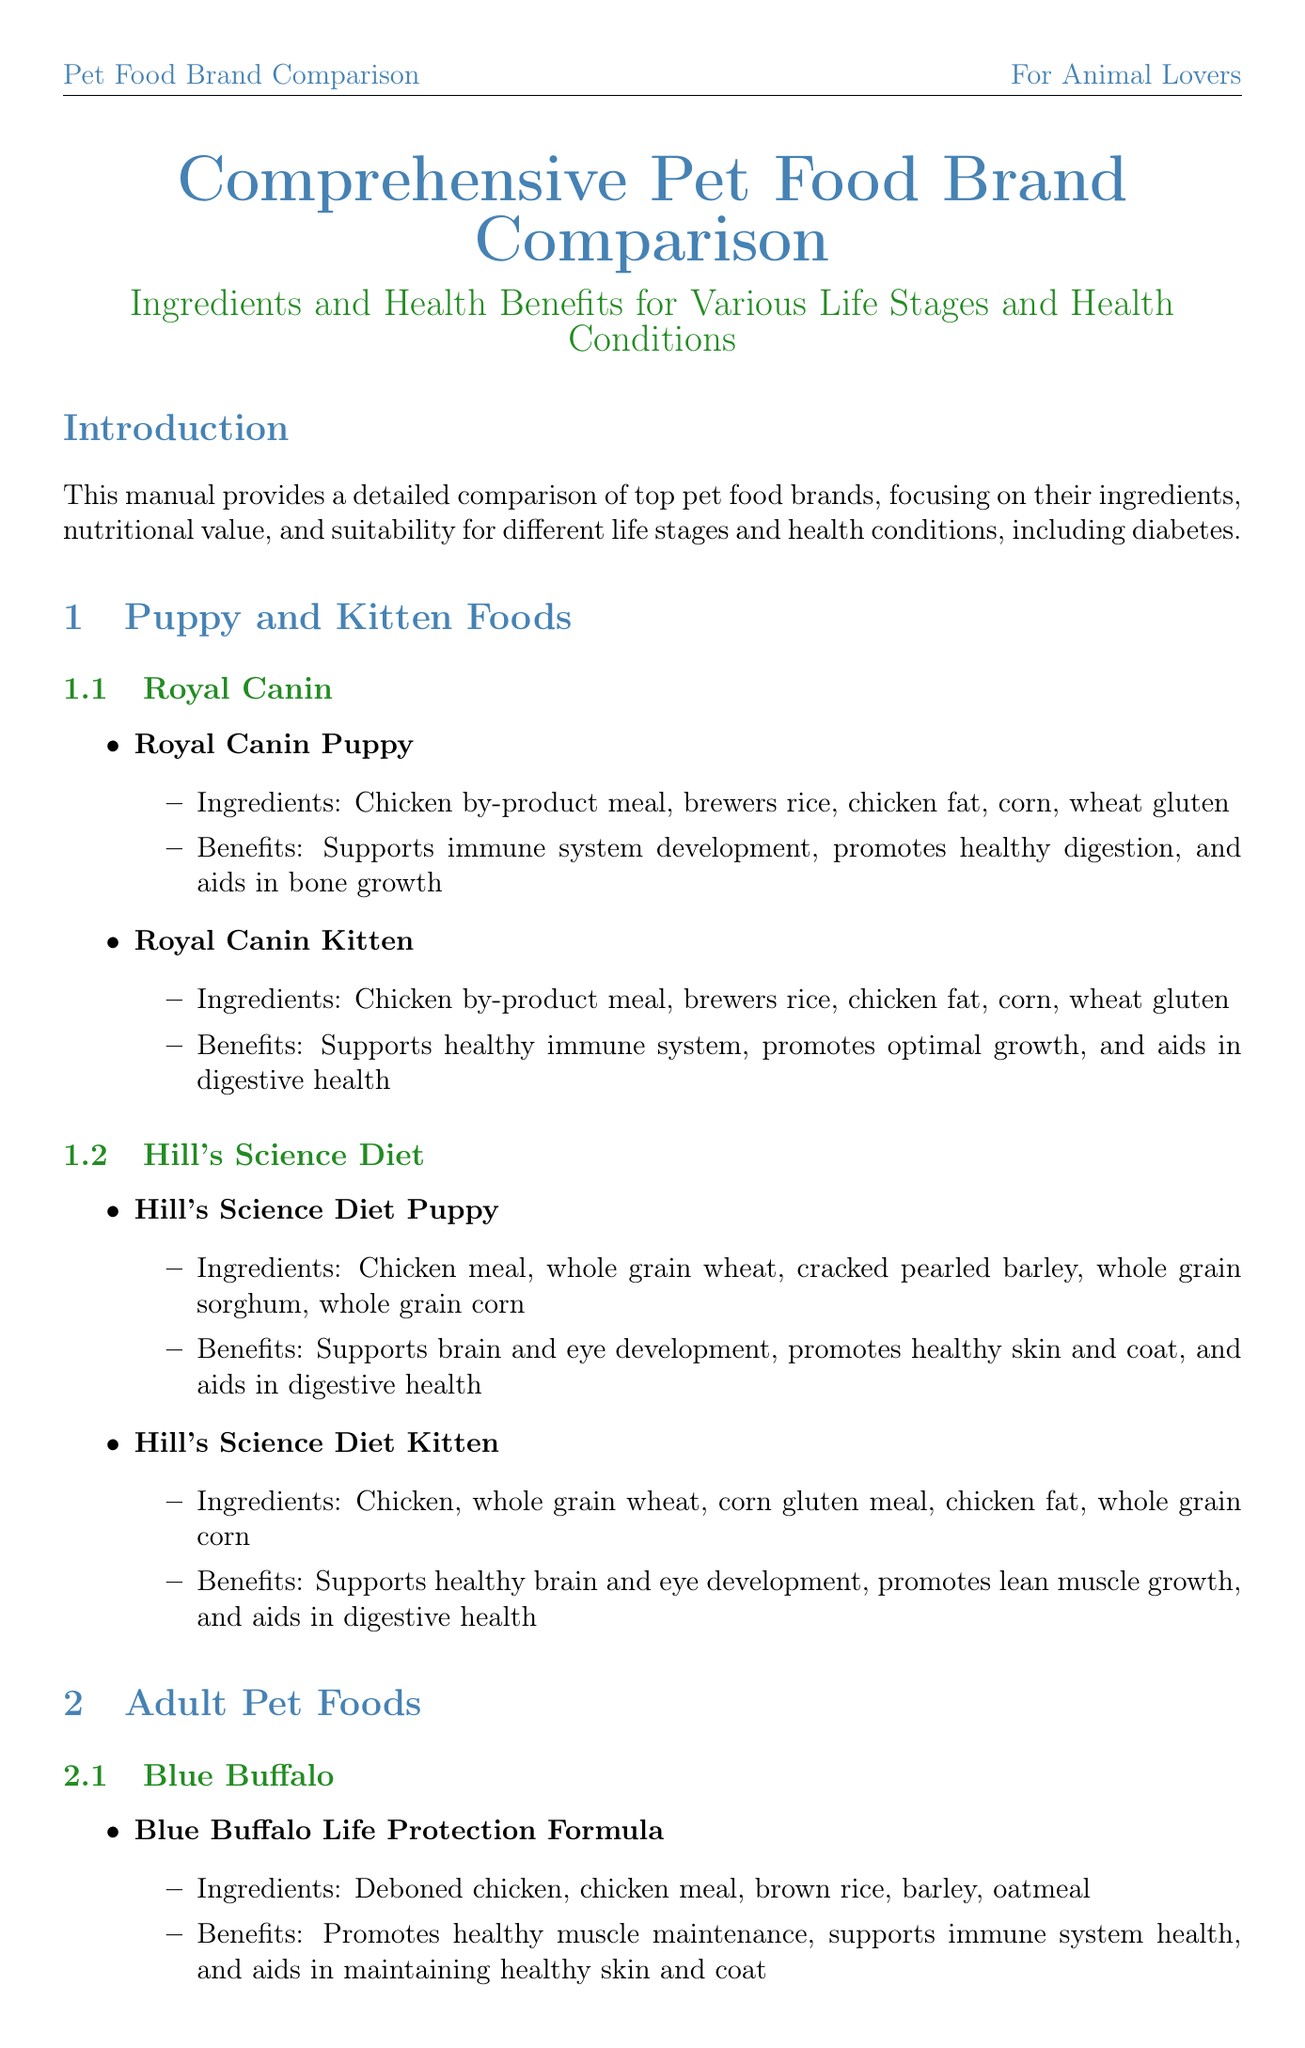What is the title of the document? The title of the document is presented at the beginning and summarizes the focus of the content.
Answer: Comprehensive Pet Food Brand Comparison: Ingredients and Health Benefits for Various Life Stages and Health Conditions Which brand offers a product suitable for diabetic pets? The section on diabetic-friendly pet foods lists brands that provide products for diabetic pets.
Answer: Royal Canin What is one ingredient in Royal Canin Glycobalance? The product description lists several ingredients for Royal Canin Glycobalance, and one of them is explicitly mentioned.
Answer: Chicken by-product meal What is the benefit of Hill's Science Diet Kitten? Each product section outlines specific benefits connected to the food, and Hill's Science Diet Kitten has notable attributes.
Answer: Supports healthy brain and eye development How many products does Blue Buffalo have listed? The document details each brand's offerings, specifically under the adult pet foods section.
Answer: One What health condition does Hill's Prescription Diet w/d address? The document describes the purpose of specific food products and their targeted health issues.
Answer: Regulates blood glucose levels Which pet food category includes products for puppies? The sections of the document are organized by pet life stages, making it clear which category contains puppy food.
Answer: Puppy and Kitten Foods What health benefit does Wellness Complete Health Senior provide? The benefits section associated with each senior pet food product includes suitable health advantages.
Answer: Supports joint health 